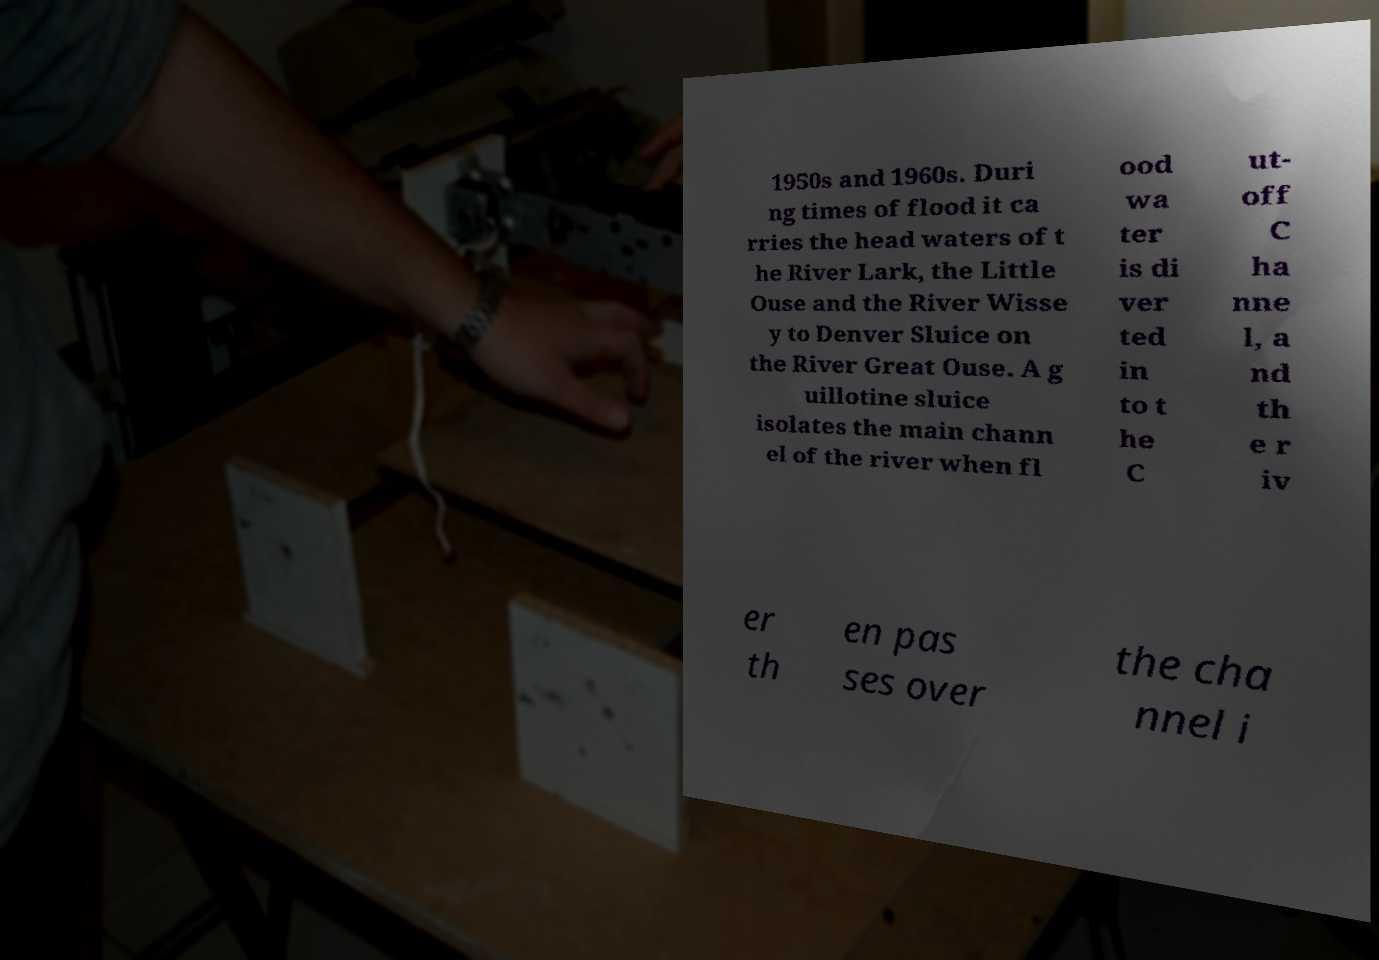For documentation purposes, I need the text within this image transcribed. Could you provide that? 1950s and 1960s. Duri ng times of flood it ca rries the head waters of t he River Lark, the Little Ouse and the River Wisse y to Denver Sluice on the River Great Ouse. A g uillotine sluice isolates the main chann el of the river when fl ood wa ter is di ver ted in to t he C ut- off C ha nne l, a nd th e r iv er th en pas ses over the cha nnel i 